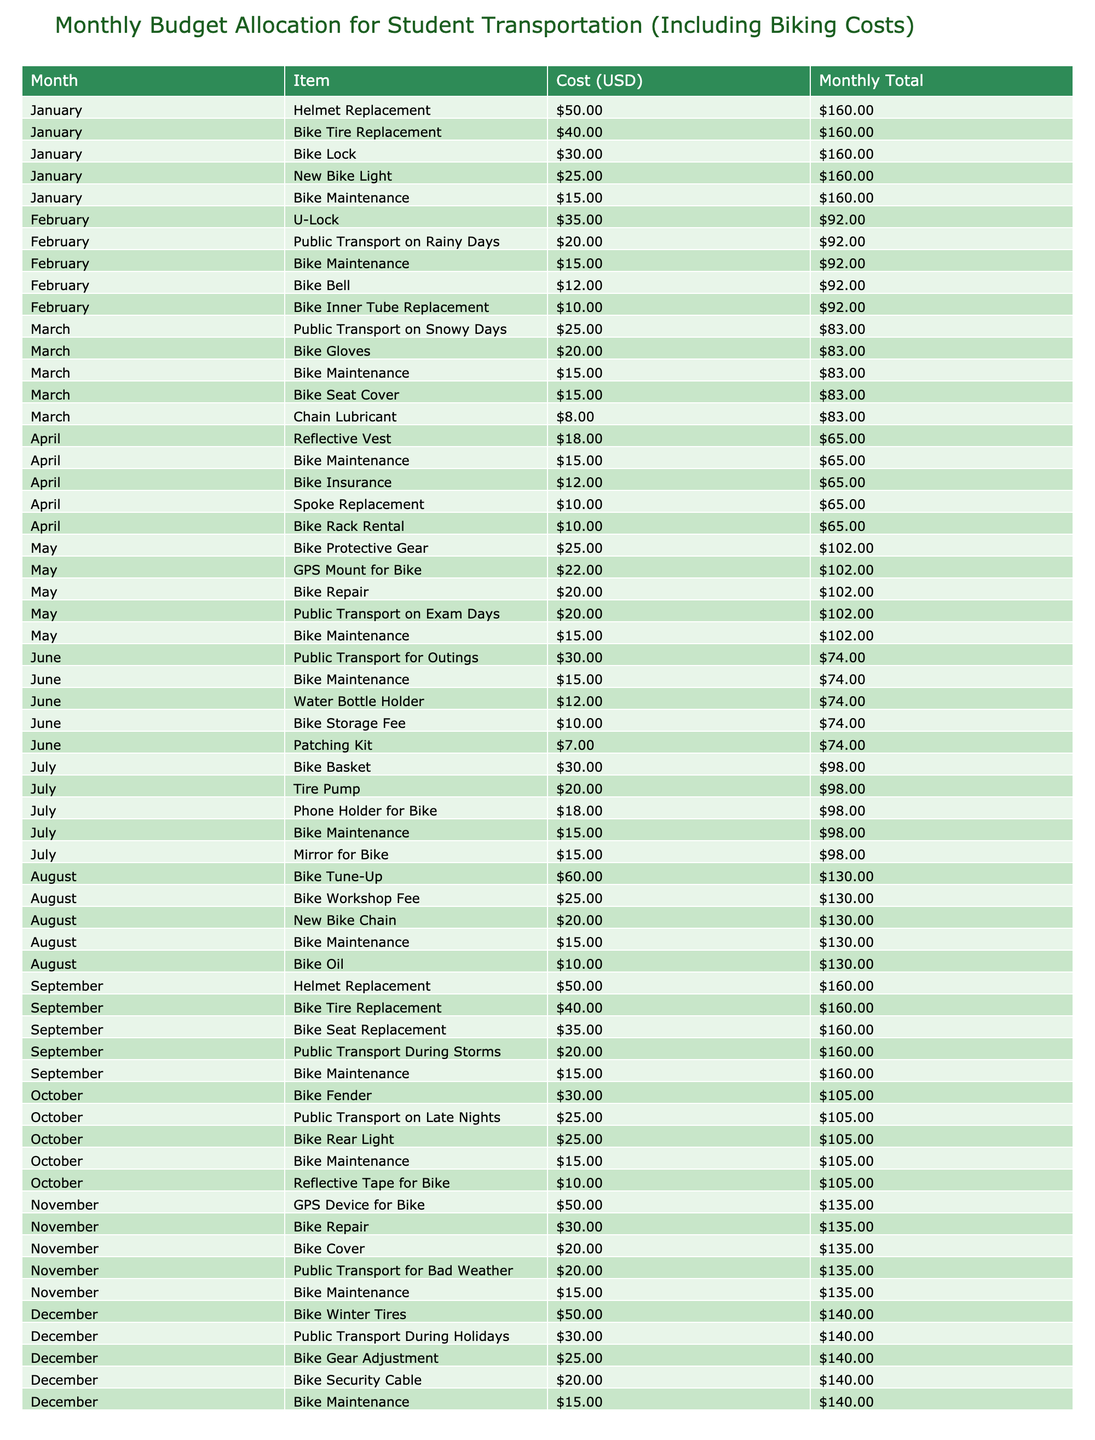What is the total cost for biking in June? In June, the biking costs are: Bike Maintenance ($15), Patching Kit ($7), Water Bottle Holder ($12), Bike Storage Fee ($10), and Public Transport for Outings ($30). Adding these amounts: 15 + 7 + 12 + 10 + 30 = 74.
Answer: 74 How much was spent on bike maintenance over the year? The biking maintenance cost for each month is $15 and it occurs in all twelve months (January to December). Therefore, 15 * 12 = 180.
Answer: 180 Which month had the highest single item cost for biking? By analyzing the costs, the highest single item is the Bike Tune-Up in August, which costs $60. It is the only cost above $50 listed in the table.
Answer: 60 Is the total biking cost in November greater than in January? In January, the total biking cost is $15 (Bike Maintenance) + $25 (New Bike Light) + $50 (Helmet Replacement) + $30 (Bike Lock) + $40 (Bike Tire Replacement) = $160. In November, the total cost is $15 (Bike Maintenance) + $30 (Bike Repair) + $50 (GPS Device for Bike) + $20 (Bike Cover) + $20 (Public Transport for Bad Weather) = $135. Since $160 > $135, the statement is true.
Answer: Yes What is the average monthly cost for biking items over the year? To find the average, we first sum all the costs for the year. The total cost comes to $770 (calculated from the table). Since there are 12 months, we divide the total by 12: 770 / 12 ≈ 64.17.
Answer: 64.17 Which month has the least expenditure on biking? Reviewing the total monthly costs, February has the least expenditure which totals $87. The individual costs do not exceed this amount in any other month throughout the year.
Answer: February How much did the bike accessories (excluding maintenance costs) cost in April? In April, the costs excluding maintenance are for Spoke Replacement ($10), Reflective Vest ($18), Bike Rack Rental ($10), and Bike Insurance ($12). Adding these amounts gives: 10 + 18 + 10 + 12 = 50.
Answer: 50 During which month did public transport costs exceed $30? Analyzing the table, public transport costs exceed $30 in June ($30 for Outings) and December ($30 during Holidays), but no other month lists transport costs above that amount.
Answer: June and December What is the total cost of biking gear (items that support riding) in September? The biking gear costs in September are the Bike Tire Replacement ($40), Bike Seat Replacement ($35), and Helmet Replacement ($50). Adding these gives 40 + 35 + 50 = 125.
Answer: 125 